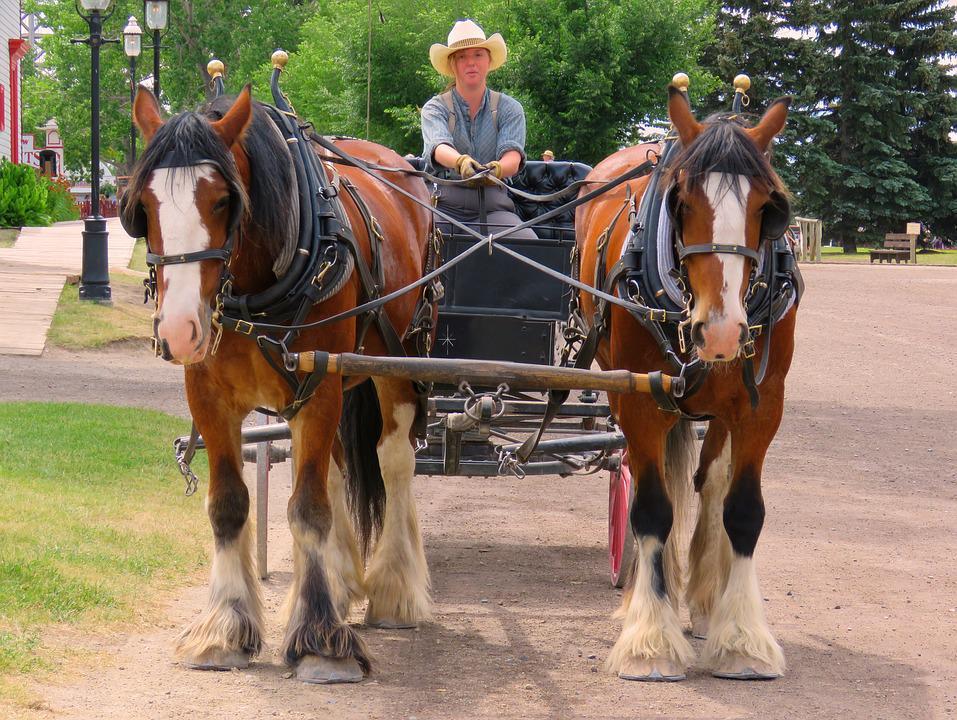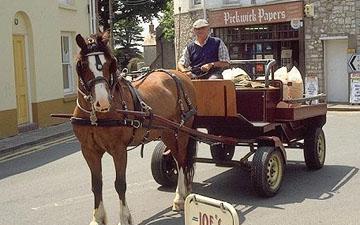The first image is the image on the left, the second image is the image on the right. Given the left and right images, does the statement "In one of the images the wagon is being pulled by two horses." hold true? Answer yes or no. Yes. 